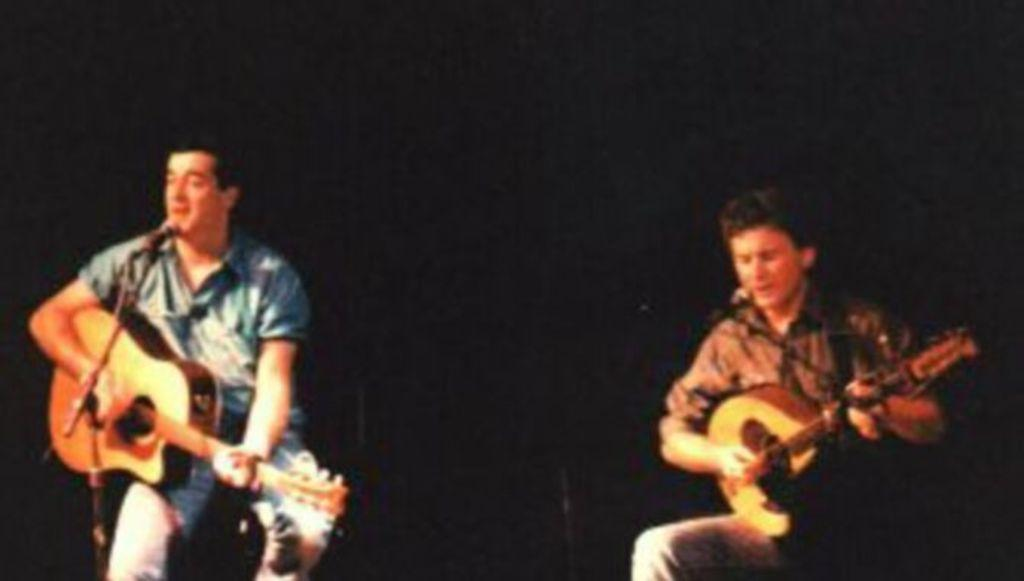How many people are in the image? There are two persons in the image. What are the two persons doing in the image? One person is playing a guitar, and the other person is singing on a microphone. How are the two persons positioned in the image? The two persons are sitting on a chair. What color is the paint on the engine in the image? There is no paint or engine present in the image; it features two persons, one playing a guitar and the other singing on a microphone. 